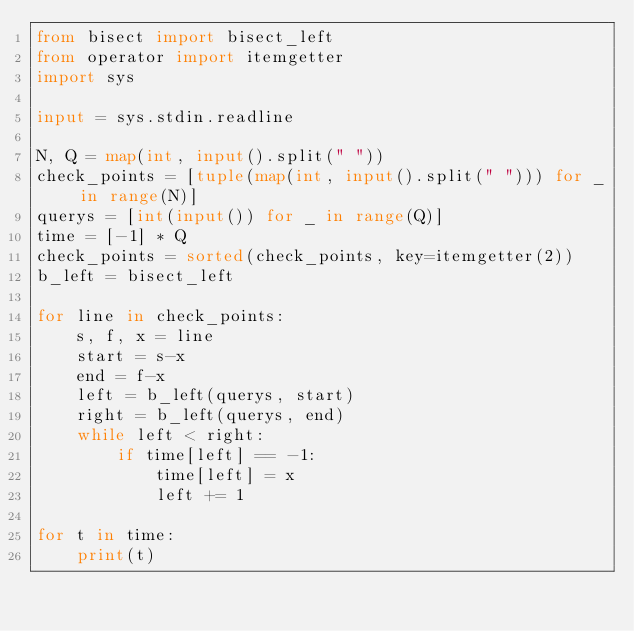<code> <loc_0><loc_0><loc_500><loc_500><_Python_>from bisect import bisect_left
from operator import itemgetter
import sys

input = sys.stdin.readline

N, Q = map(int, input().split(" "))
check_points = [tuple(map(int, input().split(" "))) for _ in range(N)]
querys = [int(input()) for _ in range(Q)]
time = [-1] * Q
check_points = sorted(check_points, key=itemgetter(2))
b_left = bisect_left

for line in check_points:
    s, f, x = line
    start = s-x
    end = f-x
    left = b_left(querys, start)
    right = b_left(querys, end)
    while left < right:
        if time[left] == -1:
            time[left] = x
            left += 1

for t in time:
    print(t)
</code> 